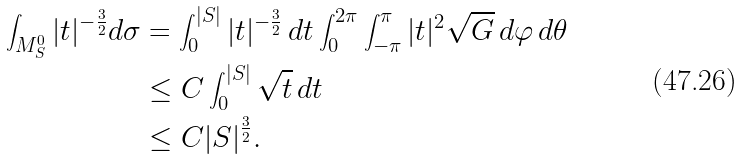Convert formula to latex. <formula><loc_0><loc_0><loc_500><loc_500>\int _ { M _ { S } ^ { 0 } } | t | ^ { - \frac { 3 } { 2 } } d \sigma & = \int _ { 0 } ^ { | S | } | t | ^ { - \frac { 3 } { 2 } } \, d t \int _ { 0 } ^ { 2 \pi } \int _ { - \pi } ^ { \pi } | t | ^ { 2 } \sqrt { G } \, d \varphi \, d \theta \\ & \leq C \int _ { 0 } ^ { | S | } \sqrt { t } \, d t \\ & \leq C | S | ^ { \frac { 3 } { 2 } } . \\</formula> 